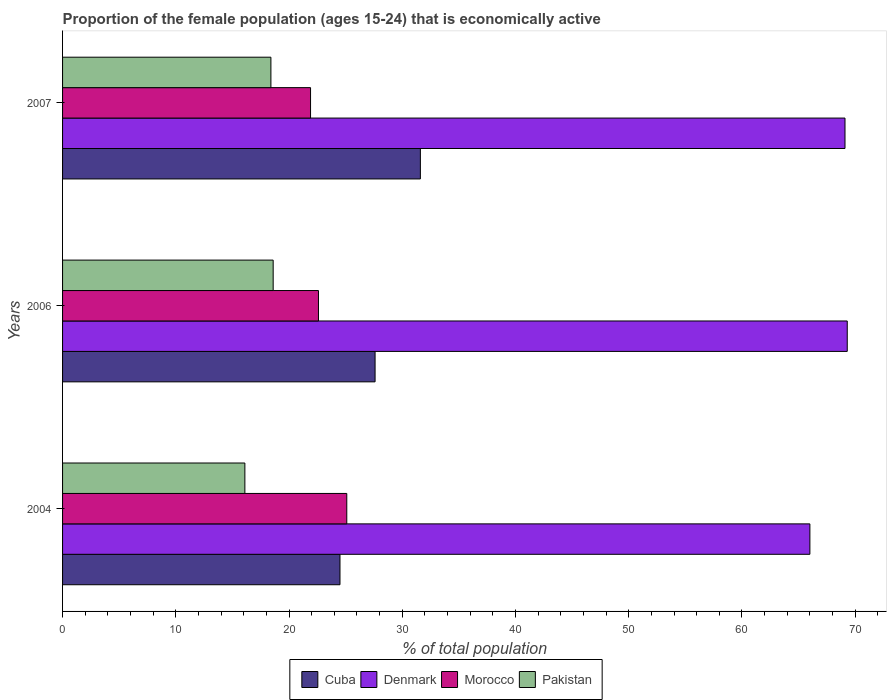How many different coloured bars are there?
Your answer should be compact. 4. How many groups of bars are there?
Your response must be concise. 3. Are the number of bars per tick equal to the number of legend labels?
Make the answer very short. Yes. How many bars are there on the 3rd tick from the top?
Keep it short and to the point. 4. How many bars are there on the 3rd tick from the bottom?
Offer a very short reply. 4. In how many cases, is the number of bars for a given year not equal to the number of legend labels?
Provide a succinct answer. 0. What is the proportion of the female population that is economically active in Morocco in 2004?
Your answer should be compact. 25.1. Across all years, what is the maximum proportion of the female population that is economically active in Pakistan?
Make the answer very short. 18.6. Across all years, what is the minimum proportion of the female population that is economically active in Cuba?
Ensure brevity in your answer.  24.5. What is the total proportion of the female population that is economically active in Denmark in the graph?
Keep it short and to the point. 204.4. What is the difference between the proportion of the female population that is economically active in Morocco in 2004 and that in 2007?
Provide a short and direct response. 3.2. What is the difference between the proportion of the female population that is economically active in Cuba in 2004 and the proportion of the female population that is economically active in Pakistan in 2007?
Your response must be concise. 6.1. What is the average proportion of the female population that is economically active in Morocco per year?
Your answer should be very brief. 23.2. In the year 2004, what is the difference between the proportion of the female population that is economically active in Cuba and proportion of the female population that is economically active in Denmark?
Provide a succinct answer. -41.5. In how many years, is the proportion of the female population that is economically active in Cuba greater than 68 %?
Ensure brevity in your answer.  0. What is the ratio of the proportion of the female population that is economically active in Cuba in 2006 to that in 2007?
Give a very brief answer. 0.87. Is the proportion of the female population that is economically active in Pakistan in 2004 less than that in 2006?
Offer a very short reply. Yes. Is the difference between the proportion of the female population that is economically active in Cuba in 2004 and 2006 greater than the difference between the proportion of the female population that is economically active in Denmark in 2004 and 2006?
Make the answer very short. Yes. What is the difference between the highest and the second highest proportion of the female population that is economically active in Cuba?
Ensure brevity in your answer.  4. What is the difference between the highest and the lowest proportion of the female population that is economically active in Denmark?
Ensure brevity in your answer.  3.3. Is the sum of the proportion of the female population that is economically active in Cuba in 2006 and 2007 greater than the maximum proportion of the female population that is economically active in Pakistan across all years?
Provide a succinct answer. Yes. Is it the case that in every year, the sum of the proportion of the female population that is economically active in Morocco and proportion of the female population that is economically active in Denmark is greater than the sum of proportion of the female population that is economically active in Pakistan and proportion of the female population that is economically active in Cuba?
Your answer should be compact. No. What does the 4th bar from the top in 2004 represents?
Your response must be concise. Cuba. What does the 2nd bar from the bottom in 2007 represents?
Provide a succinct answer. Denmark. How many bars are there?
Your answer should be very brief. 12. Are all the bars in the graph horizontal?
Your response must be concise. Yes. What is the difference between two consecutive major ticks on the X-axis?
Give a very brief answer. 10. Are the values on the major ticks of X-axis written in scientific E-notation?
Your answer should be very brief. No. Does the graph contain any zero values?
Offer a very short reply. No. How many legend labels are there?
Ensure brevity in your answer.  4. What is the title of the graph?
Provide a short and direct response. Proportion of the female population (ages 15-24) that is economically active. Does "South Sudan" appear as one of the legend labels in the graph?
Offer a very short reply. No. What is the label or title of the X-axis?
Provide a succinct answer. % of total population. What is the % of total population of Morocco in 2004?
Provide a short and direct response. 25.1. What is the % of total population in Pakistan in 2004?
Your response must be concise. 16.1. What is the % of total population of Cuba in 2006?
Your response must be concise. 27.6. What is the % of total population of Denmark in 2006?
Ensure brevity in your answer.  69.3. What is the % of total population of Morocco in 2006?
Provide a short and direct response. 22.6. What is the % of total population of Pakistan in 2006?
Offer a terse response. 18.6. What is the % of total population in Cuba in 2007?
Make the answer very short. 31.6. What is the % of total population in Denmark in 2007?
Your response must be concise. 69.1. What is the % of total population of Morocco in 2007?
Your response must be concise. 21.9. What is the % of total population in Pakistan in 2007?
Provide a succinct answer. 18.4. Across all years, what is the maximum % of total population in Cuba?
Offer a terse response. 31.6. Across all years, what is the maximum % of total population of Denmark?
Provide a short and direct response. 69.3. Across all years, what is the maximum % of total population in Morocco?
Your answer should be compact. 25.1. Across all years, what is the maximum % of total population in Pakistan?
Offer a terse response. 18.6. Across all years, what is the minimum % of total population in Denmark?
Offer a terse response. 66. Across all years, what is the minimum % of total population in Morocco?
Offer a terse response. 21.9. Across all years, what is the minimum % of total population of Pakistan?
Offer a terse response. 16.1. What is the total % of total population of Cuba in the graph?
Ensure brevity in your answer.  83.7. What is the total % of total population in Denmark in the graph?
Make the answer very short. 204.4. What is the total % of total population in Morocco in the graph?
Ensure brevity in your answer.  69.6. What is the total % of total population of Pakistan in the graph?
Give a very brief answer. 53.1. What is the difference between the % of total population of Cuba in 2004 and that in 2006?
Keep it short and to the point. -3.1. What is the difference between the % of total population in Denmark in 2004 and that in 2007?
Your response must be concise. -3.1. What is the difference between the % of total population of Morocco in 2004 and that in 2007?
Give a very brief answer. 3.2. What is the difference between the % of total population in Cuba in 2006 and that in 2007?
Offer a very short reply. -4. What is the difference between the % of total population in Morocco in 2006 and that in 2007?
Your response must be concise. 0.7. What is the difference between the % of total population in Cuba in 2004 and the % of total population in Denmark in 2006?
Your answer should be very brief. -44.8. What is the difference between the % of total population of Cuba in 2004 and the % of total population of Morocco in 2006?
Offer a very short reply. 1.9. What is the difference between the % of total population of Cuba in 2004 and the % of total population of Pakistan in 2006?
Give a very brief answer. 5.9. What is the difference between the % of total population in Denmark in 2004 and the % of total population in Morocco in 2006?
Your answer should be compact. 43.4. What is the difference between the % of total population of Denmark in 2004 and the % of total population of Pakistan in 2006?
Give a very brief answer. 47.4. What is the difference between the % of total population in Cuba in 2004 and the % of total population in Denmark in 2007?
Give a very brief answer. -44.6. What is the difference between the % of total population in Cuba in 2004 and the % of total population in Morocco in 2007?
Your answer should be compact. 2.6. What is the difference between the % of total population of Cuba in 2004 and the % of total population of Pakistan in 2007?
Give a very brief answer. 6.1. What is the difference between the % of total population in Denmark in 2004 and the % of total population in Morocco in 2007?
Offer a terse response. 44.1. What is the difference between the % of total population of Denmark in 2004 and the % of total population of Pakistan in 2007?
Your answer should be very brief. 47.6. What is the difference between the % of total population of Morocco in 2004 and the % of total population of Pakistan in 2007?
Provide a succinct answer. 6.7. What is the difference between the % of total population in Cuba in 2006 and the % of total population in Denmark in 2007?
Offer a very short reply. -41.5. What is the difference between the % of total population in Cuba in 2006 and the % of total population in Morocco in 2007?
Provide a short and direct response. 5.7. What is the difference between the % of total population in Denmark in 2006 and the % of total population in Morocco in 2007?
Provide a succinct answer. 47.4. What is the difference between the % of total population of Denmark in 2006 and the % of total population of Pakistan in 2007?
Ensure brevity in your answer.  50.9. What is the average % of total population in Cuba per year?
Your response must be concise. 27.9. What is the average % of total population in Denmark per year?
Provide a short and direct response. 68.13. What is the average % of total population in Morocco per year?
Your response must be concise. 23.2. What is the average % of total population in Pakistan per year?
Your response must be concise. 17.7. In the year 2004, what is the difference between the % of total population of Cuba and % of total population of Denmark?
Your answer should be very brief. -41.5. In the year 2004, what is the difference between the % of total population of Cuba and % of total population of Morocco?
Make the answer very short. -0.6. In the year 2004, what is the difference between the % of total population in Denmark and % of total population in Morocco?
Make the answer very short. 40.9. In the year 2004, what is the difference between the % of total population in Denmark and % of total population in Pakistan?
Keep it short and to the point. 49.9. In the year 2004, what is the difference between the % of total population of Morocco and % of total population of Pakistan?
Provide a short and direct response. 9. In the year 2006, what is the difference between the % of total population in Cuba and % of total population in Denmark?
Your response must be concise. -41.7. In the year 2006, what is the difference between the % of total population in Cuba and % of total population in Morocco?
Provide a succinct answer. 5. In the year 2006, what is the difference between the % of total population in Cuba and % of total population in Pakistan?
Offer a very short reply. 9. In the year 2006, what is the difference between the % of total population in Denmark and % of total population in Morocco?
Provide a short and direct response. 46.7. In the year 2006, what is the difference between the % of total population of Denmark and % of total population of Pakistan?
Keep it short and to the point. 50.7. In the year 2006, what is the difference between the % of total population in Morocco and % of total population in Pakistan?
Your answer should be very brief. 4. In the year 2007, what is the difference between the % of total population in Cuba and % of total population in Denmark?
Keep it short and to the point. -37.5. In the year 2007, what is the difference between the % of total population in Cuba and % of total population in Pakistan?
Provide a succinct answer. 13.2. In the year 2007, what is the difference between the % of total population in Denmark and % of total population in Morocco?
Give a very brief answer. 47.2. In the year 2007, what is the difference between the % of total population in Denmark and % of total population in Pakistan?
Provide a short and direct response. 50.7. In the year 2007, what is the difference between the % of total population of Morocco and % of total population of Pakistan?
Provide a succinct answer. 3.5. What is the ratio of the % of total population in Cuba in 2004 to that in 2006?
Offer a very short reply. 0.89. What is the ratio of the % of total population of Denmark in 2004 to that in 2006?
Keep it short and to the point. 0.95. What is the ratio of the % of total population of Morocco in 2004 to that in 2006?
Offer a terse response. 1.11. What is the ratio of the % of total population of Pakistan in 2004 to that in 2006?
Your response must be concise. 0.87. What is the ratio of the % of total population in Cuba in 2004 to that in 2007?
Give a very brief answer. 0.78. What is the ratio of the % of total population in Denmark in 2004 to that in 2007?
Provide a succinct answer. 0.96. What is the ratio of the % of total population of Morocco in 2004 to that in 2007?
Provide a succinct answer. 1.15. What is the ratio of the % of total population of Pakistan in 2004 to that in 2007?
Give a very brief answer. 0.88. What is the ratio of the % of total population in Cuba in 2006 to that in 2007?
Give a very brief answer. 0.87. What is the ratio of the % of total population of Morocco in 2006 to that in 2007?
Ensure brevity in your answer.  1.03. What is the ratio of the % of total population in Pakistan in 2006 to that in 2007?
Your answer should be very brief. 1.01. What is the difference between the highest and the second highest % of total population of Cuba?
Provide a succinct answer. 4. What is the difference between the highest and the second highest % of total population of Denmark?
Keep it short and to the point. 0.2. What is the difference between the highest and the lowest % of total population of Denmark?
Make the answer very short. 3.3. 